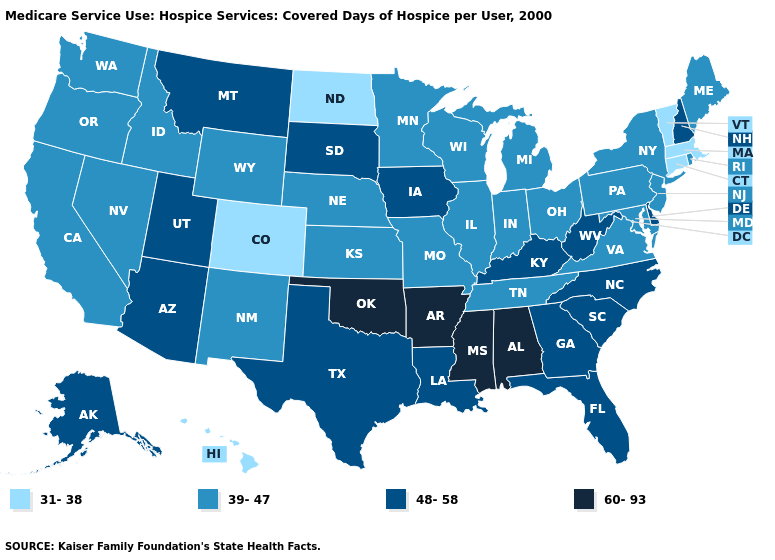Which states have the lowest value in the USA?
Be succinct. Colorado, Connecticut, Hawaii, Massachusetts, North Dakota, Vermont. Name the states that have a value in the range 31-38?
Write a very short answer. Colorado, Connecticut, Hawaii, Massachusetts, North Dakota, Vermont. Is the legend a continuous bar?
Short answer required. No. What is the value of Kentucky?
Concise answer only. 48-58. What is the value of Delaware?
Short answer required. 48-58. Is the legend a continuous bar?
Answer briefly. No. Does Missouri have a higher value than Colorado?
Answer briefly. Yes. Name the states that have a value in the range 48-58?
Give a very brief answer. Alaska, Arizona, Delaware, Florida, Georgia, Iowa, Kentucky, Louisiana, Montana, New Hampshire, North Carolina, South Carolina, South Dakota, Texas, Utah, West Virginia. What is the lowest value in the MidWest?
Be succinct. 31-38. What is the value of Indiana?
Quick response, please. 39-47. Does Massachusetts have the highest value in the USA?
Write a very short answer. No. What is the value of South Dakota?
Write a very short answer. 48-58. Does the map have missing data?
Short answer required. No. What is the value of Alaska?
Give a very brief answer. 48-58. Name the states that have a value in the range 48-58?
Write a very short answer. Alaska, Arizona, Delaware, Florida, Georgia, Iowa, Kentucky, Louisiana, Montana, New Hampshire, North Carolina, South Carolina, South Dakota, Texas, Utah, West Virginia. 